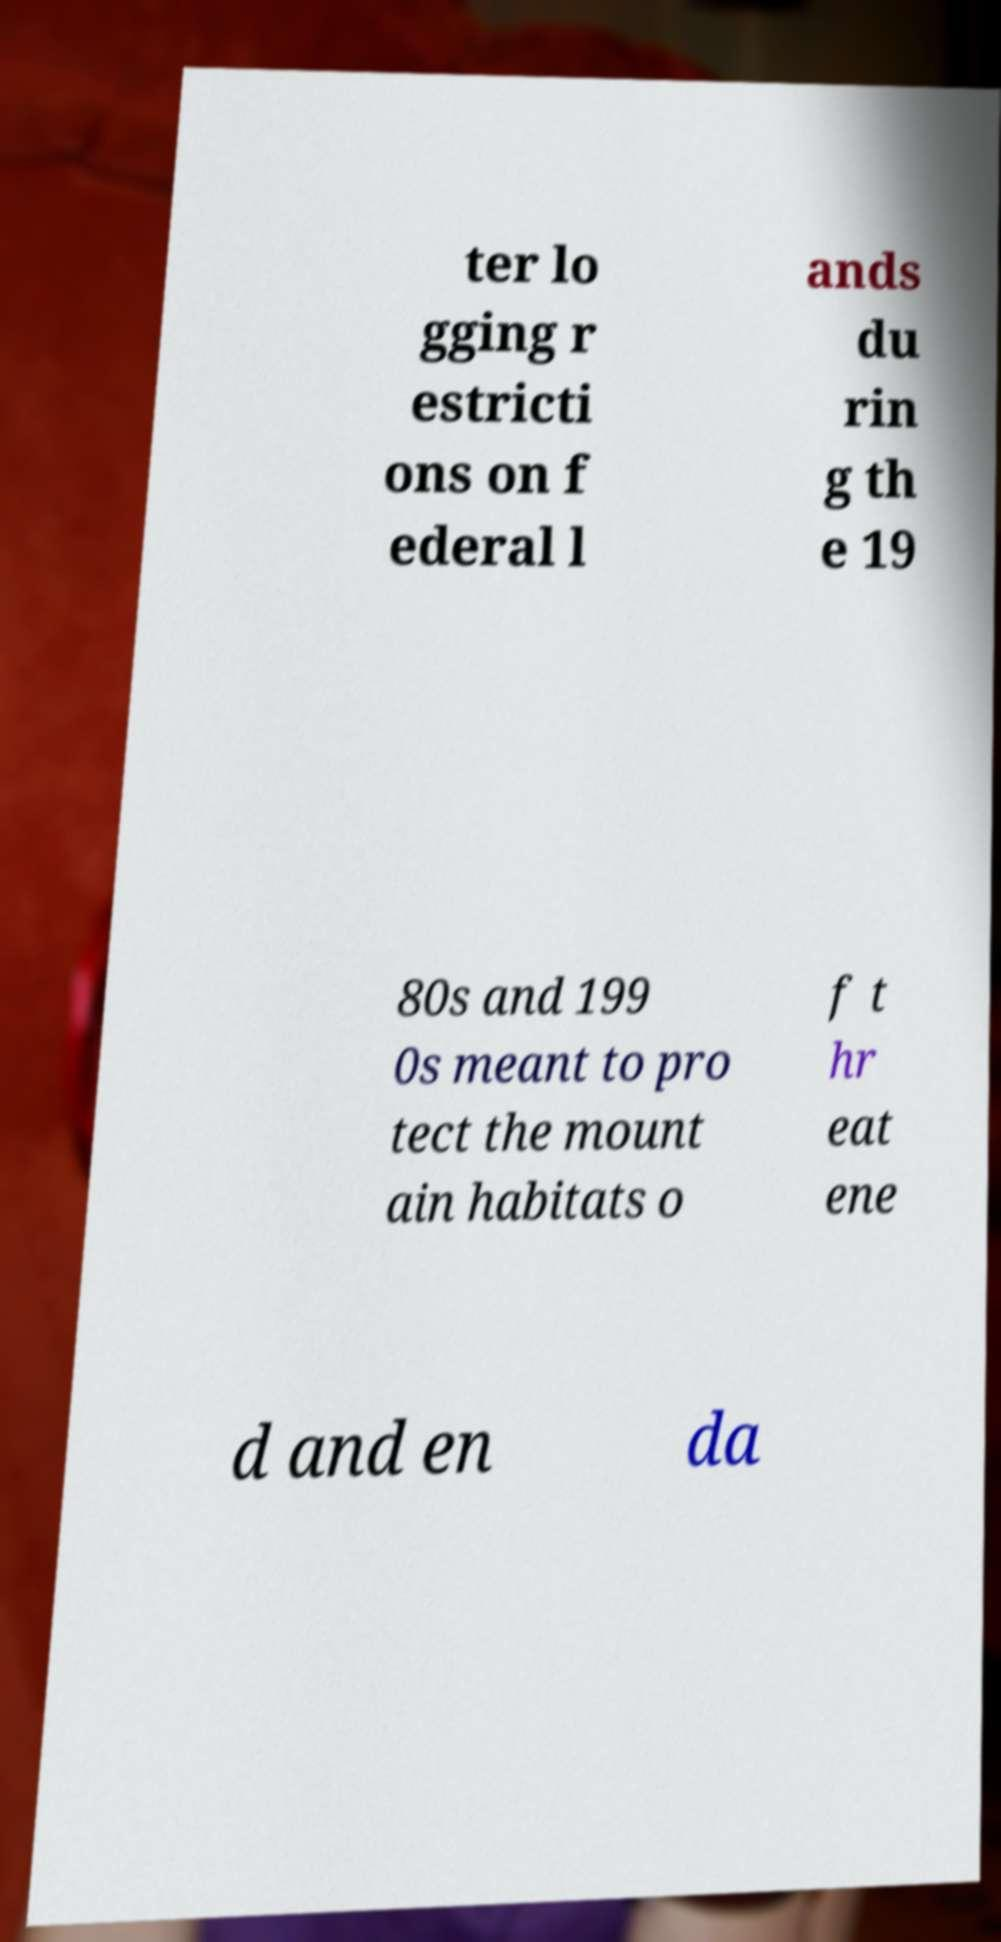Can you read and provide the text displayed in the image?This photo seems to have some interesting text. Can you extract and type it out for me? ter lo gging r estricti ons on f ederal l ands du rin g th e 19 80s and 199 0s meant to pro tect the mount ain habitats o f t hr eat ene d and en da 